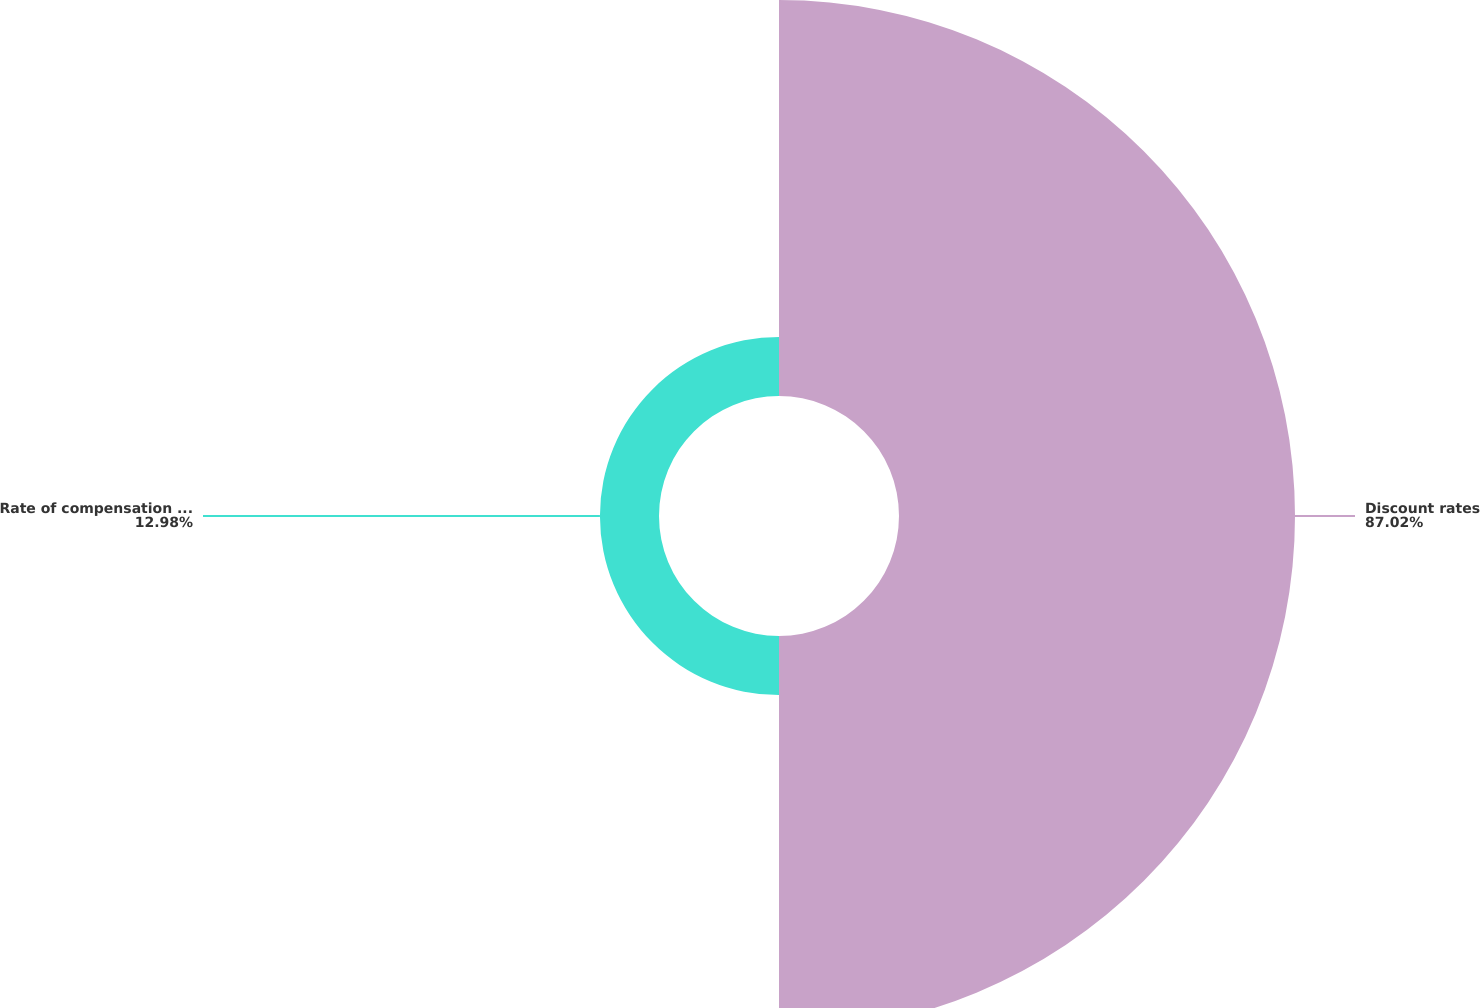<chart> <loc_0><loc_0><loc_500><loc_500><pie_chart><fcel>Discount rates<fcel>Rate of compensation increase<nl><fcel>87.02%<fcel>12.98%<nl></chart> 